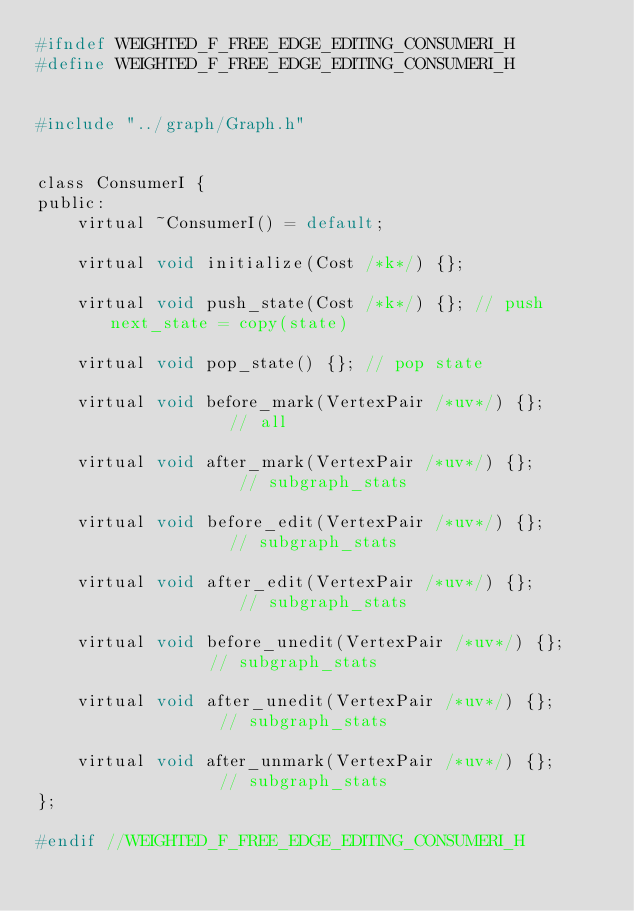Convert code to text. <code><loc_0><loc_0><loc_500><loc_500><_C_>#ifndef WEIGHTED_F_FREE_EDGE_EDITING_CONSUMERI_H
#define WEIGHTED_F_FREE_EDGE_EDITING_CONSUMERI_H


#include "../graph/Graph.h"


class ConsumerI {
public:
    virtual ~ConsumerI() = default;

    virtual void initialize(Cost /*k*/) {};

    virtual void push_state(Cost /*k*/) {}; // push next_state = copy(state)

    virtual void pop_state() {}; // pop state

    virtual void before_mark(VertexPair /*uv*/) {};             // all

    virtual void after_mark(VertexPair /*uv*/) {};              // subgraph_stats

    virtual void before_edit(VertexPair /*uv*/) {};             // subgraph_stats

    virtual void after_edit(VertexPair /*uv*/) {};              // subgraph_stats

    virtual void before_unedit(VertexPair /*uv*/) {};           // subgraph_stats

    virtual void after_unedit(VertexPair /*uv*/) {};            // subgraph_stats

    virtual void after_unmark(VertexPair /*uv*/) {};            // subgraph_stats
};

#endif //WEIGHTED_F_FREE_EDGE_EDITING_CONSUMERI_H
</code> 